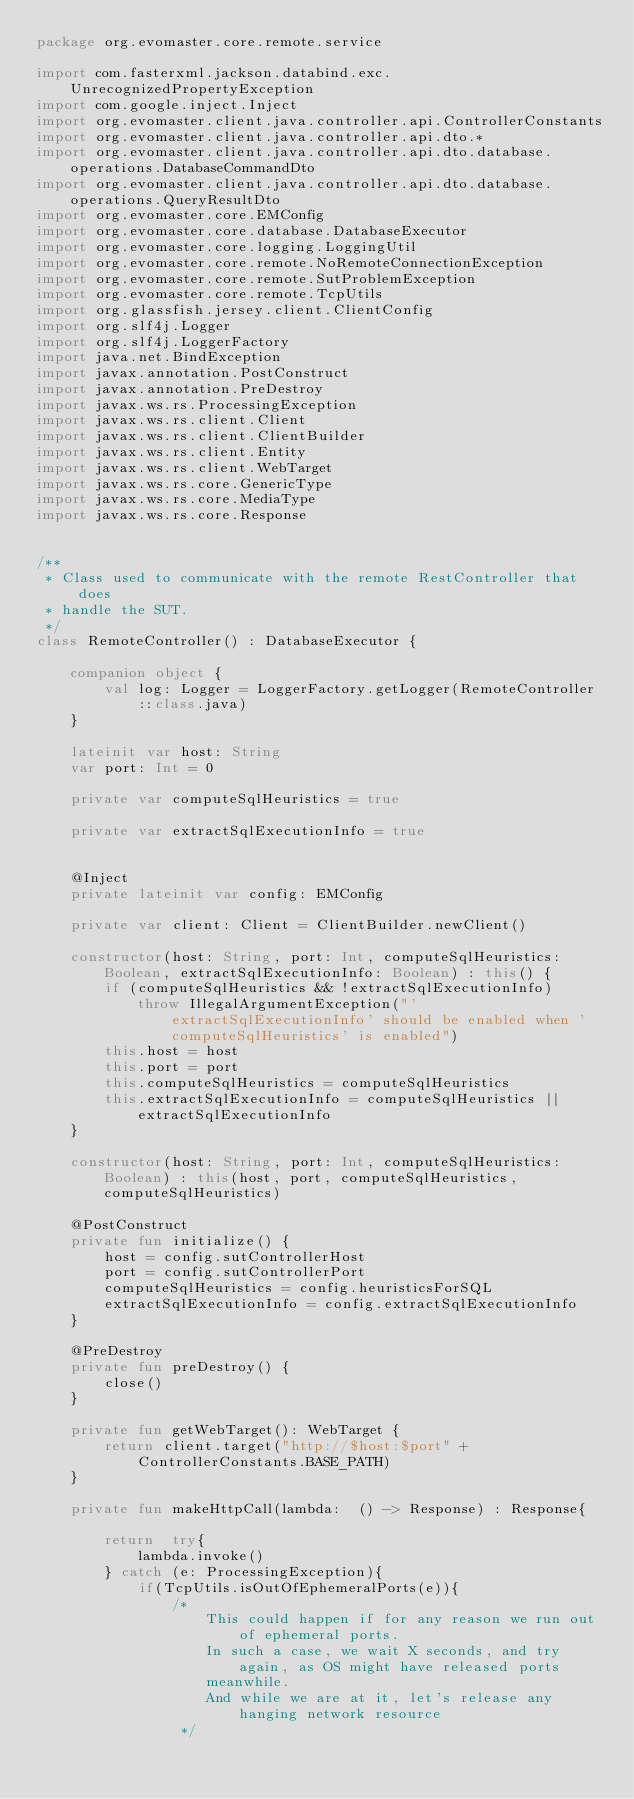Convert code to text. <code><loc_0><loc_0><loc_500><loc_500><_Kotlin_>package org.evomaster.core.remote.service

import com.fasterxml.jackson.databind.exc.UnrecognizedPropertyException
import com.google.inject.Inject
import org.evomaster.client.java.controller.api.ControllerConstants
import org.evomaster.client.java.controller.api.dto.*
import org.evomaster.client.java.controller.api.dto.database.operations.DatabaseCommandDto
import org.evomaster.client.java.controller.api.dto.database.operations.QueryResultDto
import org.evomaster.core.EMConfig
import org.evomaster.core.database.DatabaseExecutor
import org.evomaster.core.logging.LoggingUtil
import org.evomaster.core.remote.NoRemoteConnectionException
import org.evomaster.core.remote.SutProblemException
import org.evomaster.core.remote.TcpUtils
import org.glassfish.jersey.client.ClientConfig
import org.slf4j.Logger
import org.slf4j.LoggerFactory
import java.net.BindException
import javax.annotation.PostConstruct
import javax.annotation.PreDestroy
import javax.ws.rs.ProcessingException
import javax.ws.rs.client.Client
import javax.ws.rs.client.ClientBuilder
import javax.ws.rs.client.Entity
import javax.ws.rs.client.WebTarget
import javax.ws.rs.core.GenericType
import javax.ws.rs.core.MediaType
import javax.ws.rs.core.Response


/**
 * Class used to communicate with the remote RestController that does
 * handle the SUT.
 */
class RemoteController() : DatabaseExecutor {

    companion object {
        val log: Logger = LoggerFactory.getLogger(RemoteController::class.java)
    }

    lateinit var host: String
    var port: Int = 0

    private var computeSqlHeuristics = true

    private var extractSqlExecutionInfo = true


    @Inject
    private lateinit var config: EMConfig

    private var client: Client = ClientBuilder.newClient()

    constructor(host: String, port: Int, computeSqlHeuristics: Boolean, extractSqlExecutionInfo: Boolean) : this() {
        if (computeSqlHeuristics && !extractSqlExecutionInfo)
            throw IllegalArgumentException("'extractSqlExecutionInfo' should be enabled when 'computeSqlHeuristics' is enabled")
        this.host = host
        this.port = port
        this.computeSqlHeuristics = computeSqlHeuristics
        this.extractSqlExecutionInfo = computeSqlHeuristics || extractSqlExecutionInfo
    }

    constructor(host: String, port: Int, computeSqlHeuristics: Boolean) : this(host, port, computeSqlHeuristics, computeSqlHeuristics)

    @PostConstruct
    private fun initialize() {
        host = config.sutControllerHost
        port = config.sutControllerPort
        computeSqlHeuristics = config.heuristicsForSQL
        extractSqlExecutionInfo = config.extractSqlExecutionInfo
    }

    @PreDestroy
    private fun preDestroy() {
        close()
    }

    private fun getWebTarget(): WebTarget {
        return client.target("http://$host:$port" + ControllerConstants.BASE_PATH)
    }

    private fun makeHttpCall(lambda:  () -> Response) : Response{

        return  try{
            lambda.invoke()
        } catch (e: ProcessingException){
            if(TcpUtils.isOutOfEphemeralPorts(e)){
                /*
                    This could happen if for any reason we run out of ephemeral ports.
                    In such a case, we wait X seconds, and try again, as OS might have released ports
                    meanwhile.
                    And while we are at it, let's release any hanging network resource
                 */</code> 